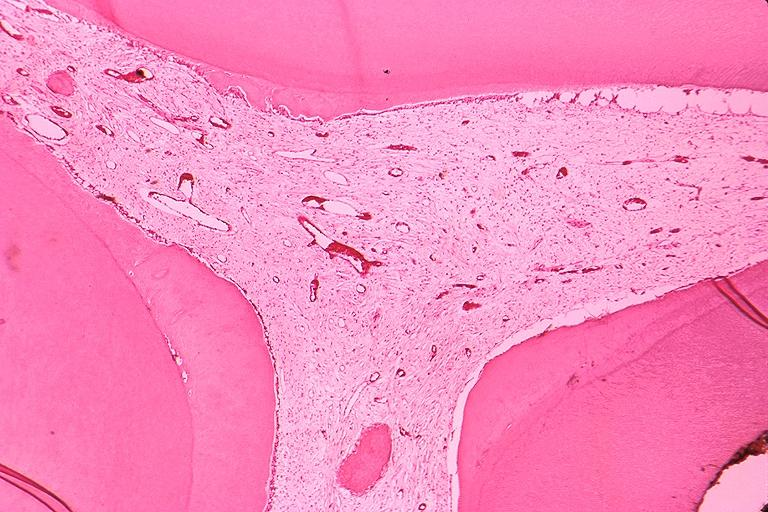s oral present?
Answer the question using a single word or phrase. Yes 